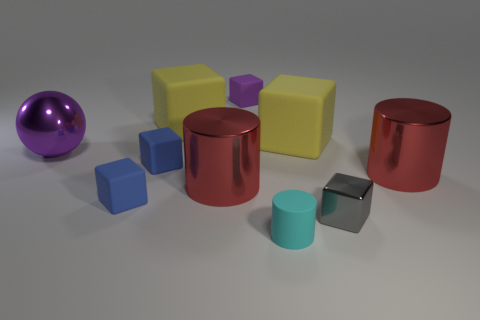Subtract all blue cylinders. How many blue cubes are left? 2 Subtract all metallic cylinders. How many cylinders are left? 1 Subtract all yellow cubes. How many cubes are left? 4 Subtract all gray blocks. Subtract all purple balls. How many blocks are left? 5 Subtract all balls. How many objects are left? 9 Add 3 large rubber things. How many large rubber things exist? 5 Subtract 1 purple spheres. How many objects are left? 9 Subtract all large cubes. Subtract all small cyan objects. How many objects are left? 7 Add 4 big purple objects. How many big purple objects are left? 5 